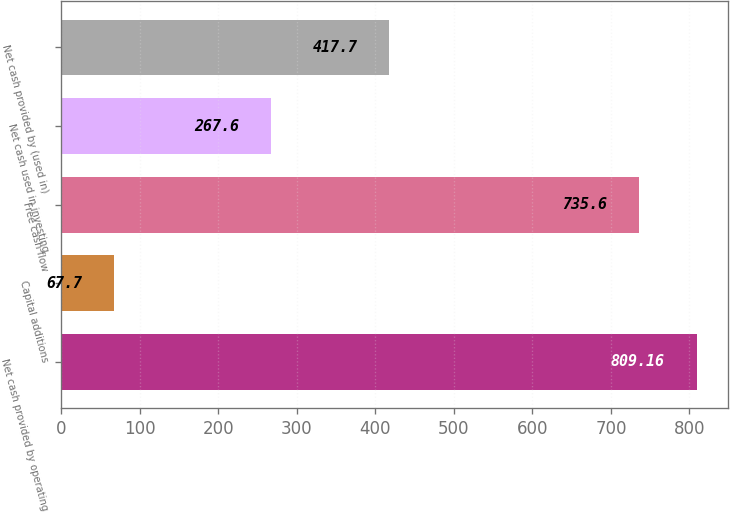<chart> <loc_0><loc_0><loc_500><loc_500><bar_chart><fcel>Net cash provided by operating<fcel>Capital additions<fcel>Free cash flow<fcel>Net cash used in investing<fcel>Net cash provided by (used in)<nl><fcel>809.16<fcel>67.7<fcel>735.6<fcel>267.6<fcel>417.7<nl></chart> 